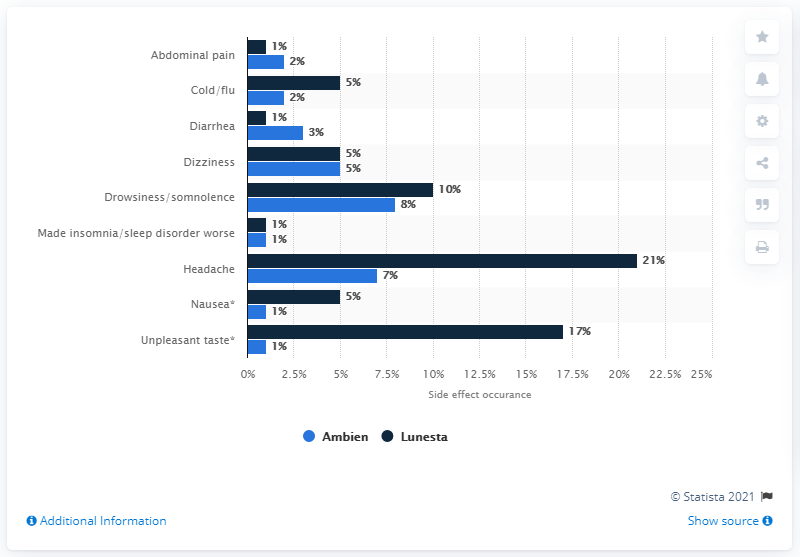Indicate a few pertinent items in this graphic. A study conducted in 2012 found that 5% of users of Ambien and Lunesta experienced dizziness. 